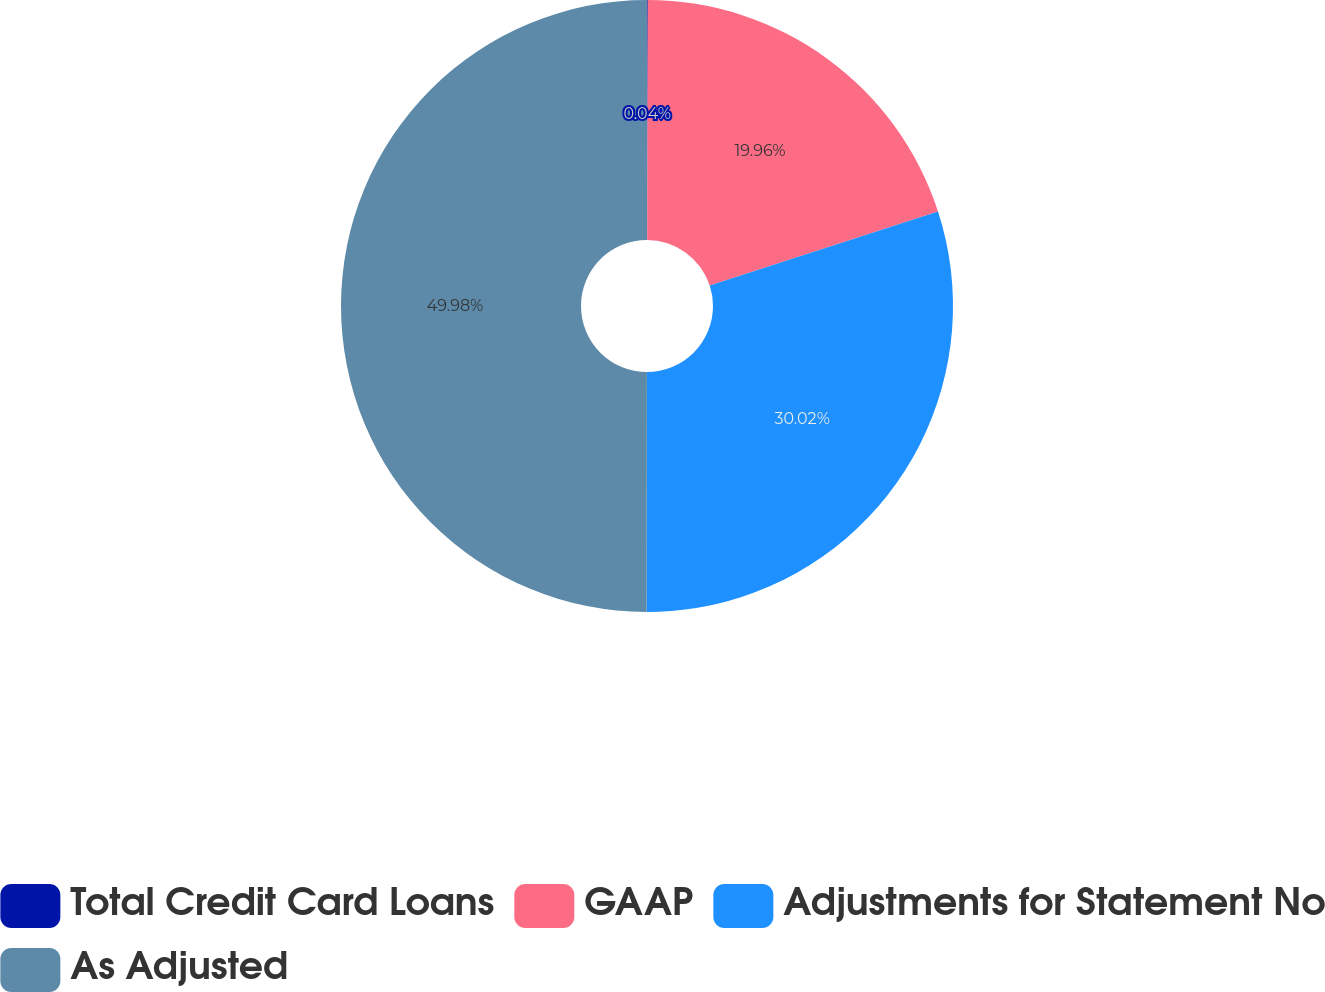Convert chart. <chart><loc_0><loc_0><loc_500><loc_500><pie_chart><fcel>Total Credit Card Loans<fcel>GAAP<fcel>Adjustments for Statement No<fcel>As Adjusted<nl><fcel>0.04%<fcel>19.96%<fcel>30.02%<fcel>49.98%<nl></chart> 